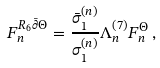<formula> <loc_0><loc_0><loc_500><loc_500>F _ { n } ^ { R _ { 6 } \bar { \partial } \Theta } = \frac { \bar { \sigma } _ { 1 } ^ { ( n ) } } { \sigma _ { 1 } ^ { ( n ) } } \Lambda _ { n } ^ { \left ( 7 \right ) } F _ { n } ^ { \Theta } \, ,</formula> 